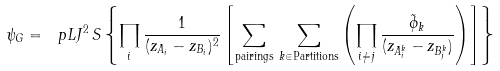Convert formula to latex. <formula><loc_0><loc_0><loc_500><loc_500>\psi _ { G } = \ p L J ^ { 2 } \, S \left \{ \prod _ { i } \frac { 1 } { ( z _ { A _ { i } } - z _ { B _ { i } } ) ^ { 2 } } \left [ \sum _ { \text {pairings} } \, \sum _ { k \in \text {Partitions} } \left ( \prod _ { i \neq j } \frac { \tilde { \phi } _ { k } } { ( z _ { A ^ { k } _ { i } } - z _ { B ^ { k } _ { j } } ) } \right ) \right ] \right \}</formula> 